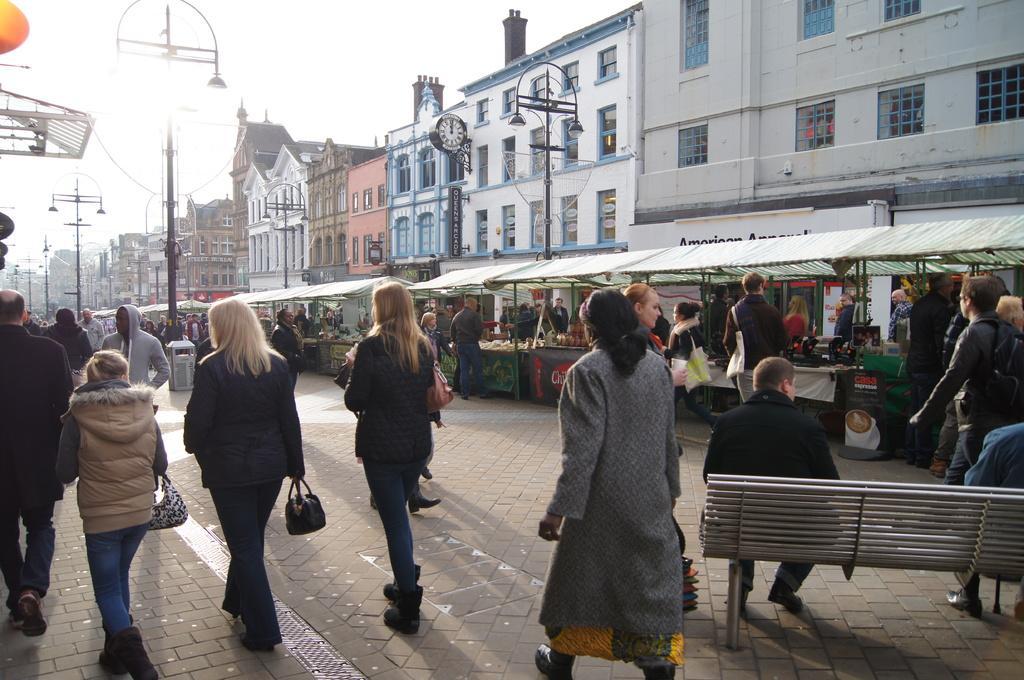Can you describe this image briefly? In this picture I can see there are few women walking here on to left side and there is a man, he is wearing hoodie and there are few other men walking here and there are few stalls on to right and there are few poles with lights and clocks and there are buildings in the backdrop and the sky is clear. 